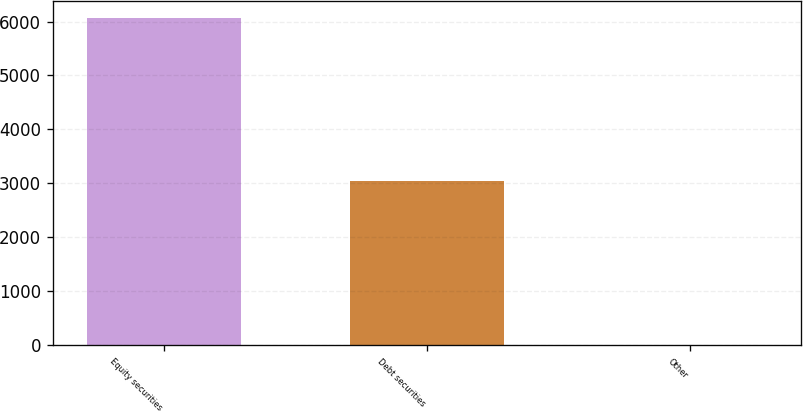<chart> <loc_0><loc_0><loc_500><loc_500><bar_chart><fcel>Equity securities<fcel>Debt securities<fcel>Other<nl><fcel>6070<fcel>3040<fcel>5<nl></chart> 